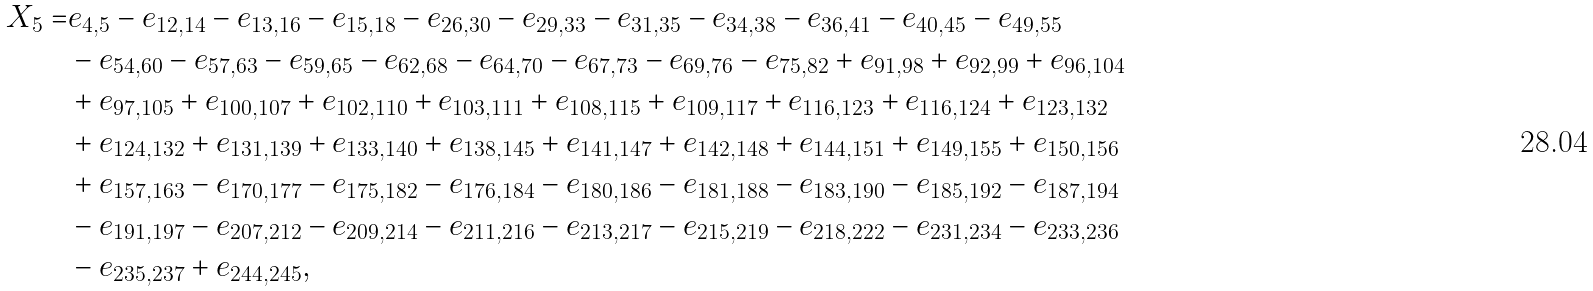Convert formula to latex. <formula><loc_0><loc_0><loc_500><loc_500>X _ { 5 } = & e _ { 4 , 5 } - e _ { 1 2 , 1 4 } - e _ { 1 3 , 1 6 } - e _ { 1 5 , 1 8 } - e _ { 2 6 , 3 0 } - e _ { 2 9 , 3 3 } - e _ { 3 1 , 3 5 } - e _ { 3 4 , 3 8 } - e _ { 3 6 , 4 1 } - e _ { 4 0 , 4 5 } - e _ { 4 9 , 5 5 } \\ & - e _ { 5 4 , 6 0 } - e _ { 5 7 , 6 3 } - e _ { 5 9 , 6 5 } - e _ { 6 2 , 6 8 } - e _ { 6 4 , 7 0 } - e _ { 6 7 , 7 3 } - e _ { 6 9 , 7 6 } - e _ { 7 5 , 8 2 } + e _ { 9 1 , 9 8 } + e _ { 9 2 , 9 9 } + e _ { 9 6 , 1 0 4 } \\ & + e _ { 9 7 , 1 0 5 } + e _ { 1 0 0 , 1 0 7 } + e _ { 1 0 2 , 1 1 0 } + e _ { 1 0 3 , 1 1 1 } + e _ { 1 0 8 , 1 1 5 } + e _ { 1 0 9 , 1 1 7 } + e _ { 1 1 6 , 1 2 3 } + e _ { 1 1 6 , 1 2 4 } + e _ { 1 2 3 , 1 3 2 } \\ & + e _ { 1 2 4 , 1 3 2 } + e _ { 1 3 1 , 1 3 9 } + e _ { 1 3 3 , 1 4 0 } + e _ { 1 3 8 , 1 4 5 } + e _ { 1 4 1 , 1 4 7 } + e _ { 1 4 2 , 1 4 8 } + e _ { 1 4 4 , 1 5 1 } + e _ { 1 4 9 , 1 5 5 } + e _ { 1 5 0 , 1 5 6 } \\ & + e _ { 1 5 7 , 1 6 3 } - e _ { 1 7 0 , 1 7 7 } - e _ { 1 7 5 , 1 8 2 } - e _ { 1 7 6 , 1 8 4 } - e _ { 1 8 0 , 1 8 6 } - e _ { 1 8 1 , 1 8 8 } - e _ { 1 8 3 , 1 9 0 } - e _ { 1 8 5 , 1 9 2 } - e _ { 1 8 7 , 1 9 4 } \\ & - e _ { 1 9 1 , 1 9 7 } - e _ { 2 0 7 , 2 1 2 } - e _ { 2 0 9 , 2 1 4 } - e _ { 2 1 1 , 2 1 6 } - e _ { 2 1 3 , 2 1 7 } - e _ { 2 1 5 , 2 1 9 } - e _ { 2 1 8 , 2 2 2 } - e _ { 2 3 1 , 2 3 4 } - e _ { 2 3 3 , 2 3 6 } \\ & - e _ { 2 3 5 , 2 3 7 } + e _ { 2 4 4 , 2 4 5 } ,</formula> 